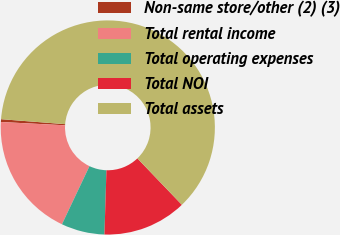Convert chart to OTSL. <chart><loc_0><loc_0><loc_500><loc_500><pie_chart><fcel>Non-same store/other (2) (3)<fcel>Total rental income<fcel>Total operating expenses<fcel>Total NOI<fcel>Total assets<nl><fcel>0.42%<fcel>18.78%<fcel>6.54%<fcel>12.66%<fcel>61.61%<nl></chart> 